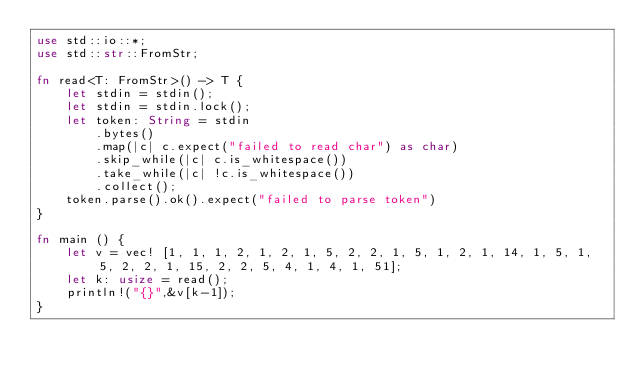Convert code to text. <code><loc_0><loc_0><loc_500><loc_500><_Rust_>use std::io::*;
use std::str::FromStr;

fn read<T: FromStr>() -> T {
    let stdin = stdin();
    let stdin = stdin.lock();
    let token: String = stdin
        .bytes()
        .map(|c| c.expect("failed to read char") as char) 
        .skip_while(|c| c.is_whitespace())
        .take_while(|c| !c.is_whitespace())
        .collect();
    token.parse().ok().expect("failed to parse token")
}

fn main () {
    let v = vec! [1, 1, 1, 2, 1, 2, 1, 5, 2, 2, 1, 5, 1, 2, 1, 14, 1, 5, 1, 5, 2, 2, 1, 15, 2, 2, 5, 4, 1, 4, 1, 51];
    let k: usize = read();
    println!("{}",&v[k-1]);
}</code> 